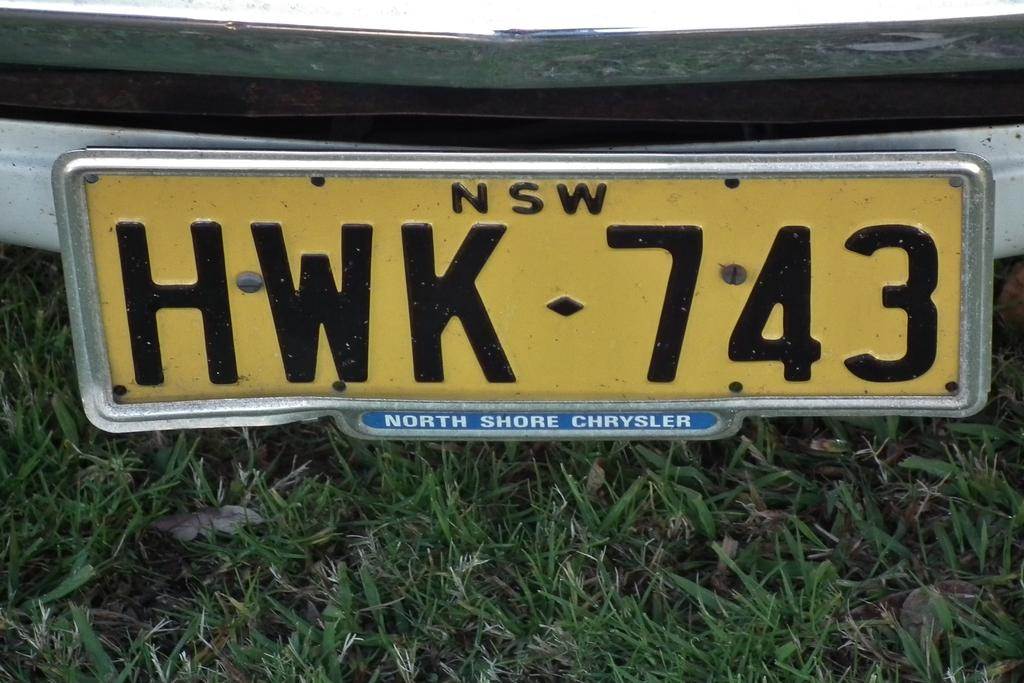What colors are present on the vehicle's number plate in the image? The vehicle's number plate is yellow, black, blue, and silver in color. What type of surface can be seen on the ground in the image? There is grass on the ground in the image. What type of lead is being used to cook the stew in the image? There is no lead or stew present in the image; it only features a vehicle's number plate and grass on the ground. 